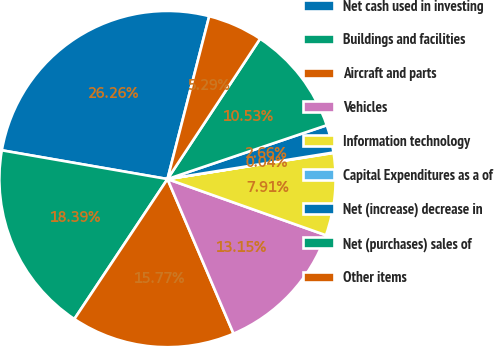Convert chart. <chart><loc_0><loc_0><loc_500><loc_500><pie_chart><fcel>Net cash used in investing<fcel>Buildings and facilities<fcel>Aircraft and parts<fcel>Vehicles<fcel>Information technology<fcel>Capital Expenditures as a of<fcel>Net (increase) decrease in<fcel>Net (purchases) sales of<fcel>Other items<nl><fcel>26.26%<fcel>18.39%<fcel>15.77%<fcel>13.15%<fcel>7.91%<fcel>0.04%<fcel>2.66%<fcel>10.53%<fcel>5.29%<nl></chart> 